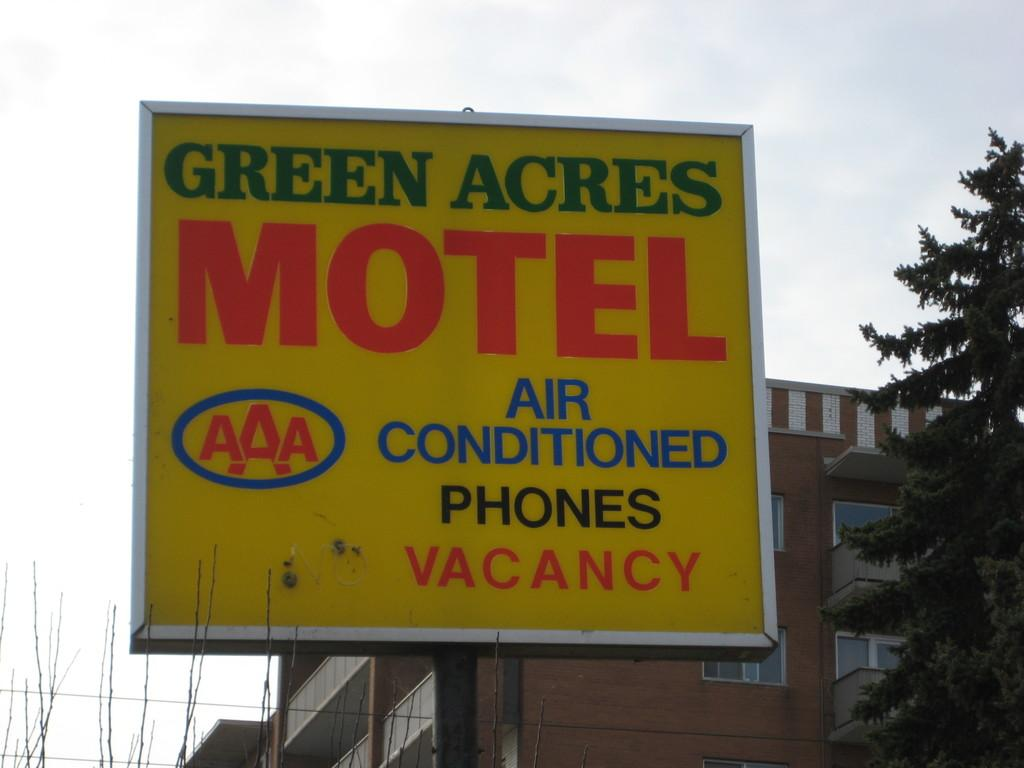<image>
Describe the image concisely. a sign with the word motel on it outside 